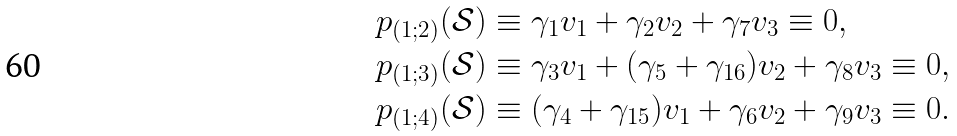<formula> <loc_0><loc_0><loc_500><loc_500>p _ { ( 1 ; 2 ) } ( \mathcal { S } ) & \equiv \gamma _ { 1 } v _ { 1 } + \gamma _ { 2 } v _ { 2 } + \gamma _ { 7 } v _ { 3 } \equiv 0 , \\ p _ { ( 1 ; 3 ) } ( \mathcal { S } ) & \equiv \gamma _ { 3 } v _ { 1 } + ( \gamma _ { 5 } + \gamma _ { 1 6 } ) v _ { 2 } + \gamma _ { 8 } v _ { 3 } \equiv 0 , \\ p _ { ( 1 ; 4 ) } ( \mathcal { S } ) & \equiv ( \gamma _ { 4 } + \gamma _ { 1 5 } ) v _ { 1 } + \gamma _ { 6 } v _ { 2 } + \gamma _ { 9 } v _ { 3 } \equiv 0 .</formula> 